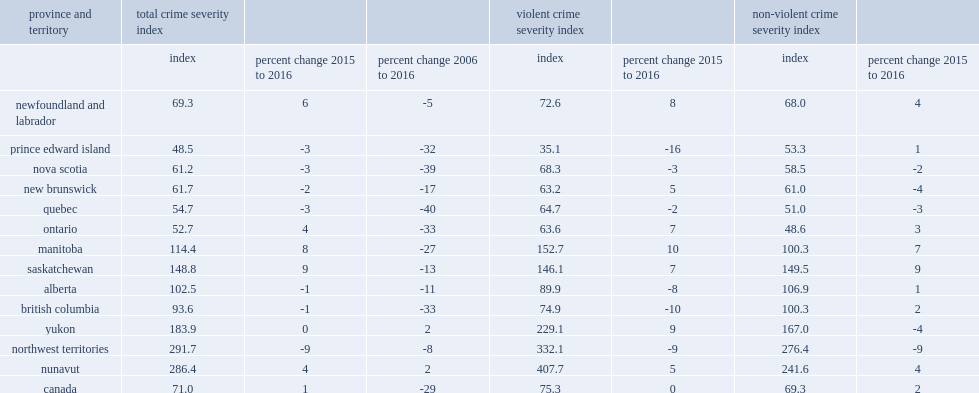Comparing to 2015, how many percentage point has northwest territories decreased in their crime severity index (csi) in 2016? 9. Comparing to 2015, how many percentage point has quebec decreased in their crime severity index (csi) in 2016? 3. Comparing to 2015, how many percentage point has prince edward island decreased in their crime severity index (csi) in 2016? 3. Comparing to 2015, how many percentage point has nova scotia decreased in their crime severity index (csi) in 2016? 3. Comparing to 2015, how many percentage point has new brunswick decreased in their crime severity index (csi) in 2016? 2. Comparing to 2015, how many percentage point has alberta decreased in their crime severity index (csi) in 2016? 1. Comparing to 2015, how many percentage point has british columbia decreased in their crime severity index (csi) in 2016? 1. Comparing to 2015, what is the percentage point of the declines in violent csi reported by british columbia in 2016? 10. Comparing to 2015, what is the percentage point of the declines in violent csi reported by northwest territories in 2016? 9. Comparing to 2015, what is the percentage point of the declines in violent csi reported by alberta in 2016? 8. Comparing to 2015, what is the percentage point of the increases in violent csi reported by manitoba in 2016? 10.0. Comparing to 2015, what is the percentage point of the increases in violent csi reported by yukon in 2016? 9.0. Which two places reported the lowest non-violent csis? Quebec ontario. Comparing to 2015, what is the percentage point of the declines in violent csi reported by northwest territories in 2016? 9. Comparing to 2015, what is the percentage point of the declines in violent csi reported by new brunswick in 2016? 4. Comparing to 2015, what is the percentage point of the declines in violent csi reported by yukon in 2016? 4. 